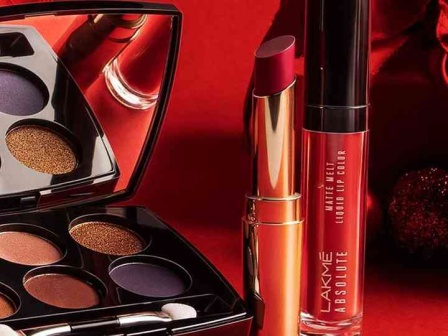Imagine if these makeup products had magical properties. What could their powers be? Imagine if these Lakme makeup products possessed magical properties! The eyeshadow palette would not only enhance your eyes but also grant you the power of mesmerizing gaze—those who look into your eyes are compelled to tell you the truth. The metallic orange lipstick, when applied, would give you the ability to speak any language fluently, breaking all communication barriers. The deep red liquid lip color would provide the wearer with an aura of confidence and charisma, making them irresistible and influential in any social or professional situation. With these magical makeup items, not only would you look stunning, but you would also possess extraordinary abilities that could change your life in the most enchanting ways. 